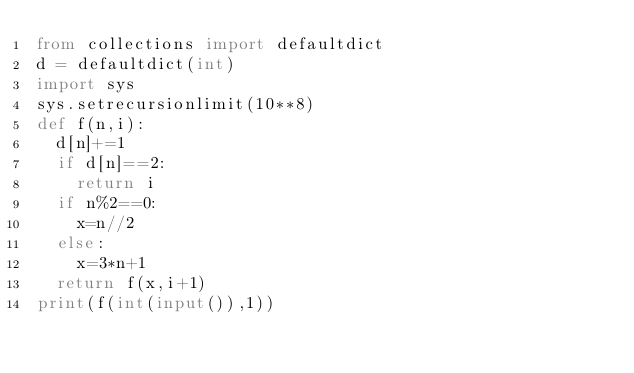<code> <loc_0><loc_0><loc_500><loc_500><_Python_>from collections import defaultdict
d = defaultdict(int)
import sys
sys.setrecursionlimit(10**8)
def f(n,i):
  d[n]+=1
  if d[n]==2:
    return i
  if n%2==0:
    x=n//2
  else:
    x=3*n+1
  return f(x,i+1)
print(f(int(input()),1))

</code> 